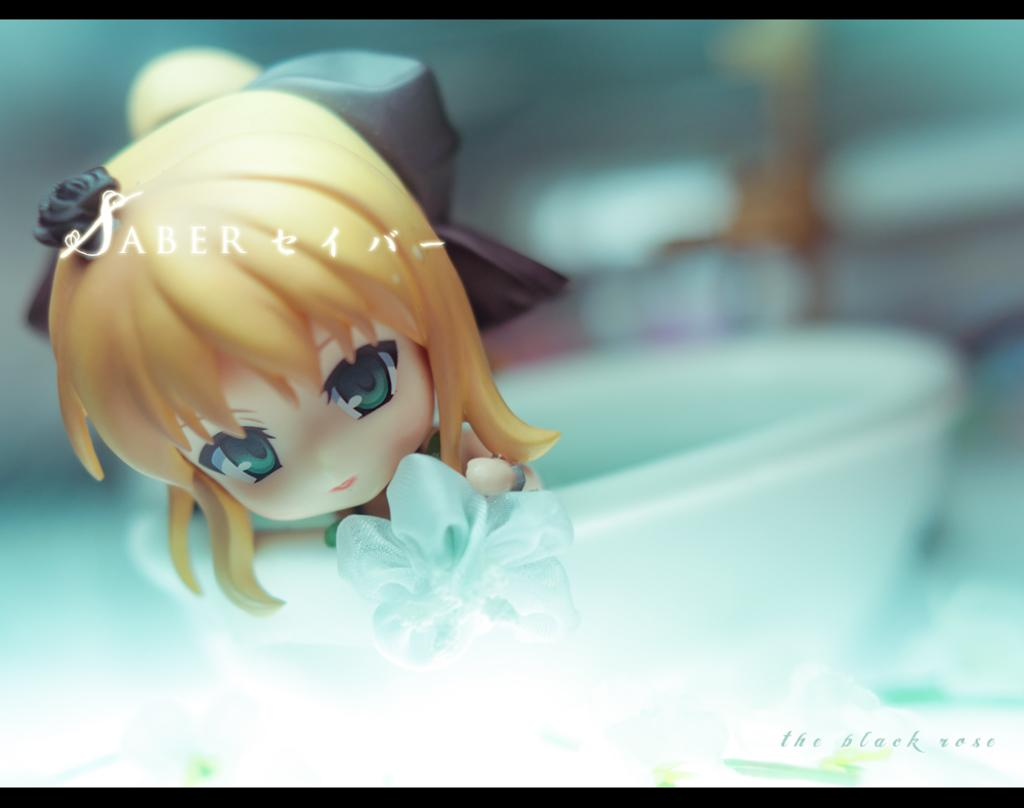What type of image is being described? The image is animated. What can be found in the image? There is a bowl in the image. What is inside the bowl? There is a toy in the bowl. Are there any words or letters in the image? Yes, there is text on the image. Can you see a donkey's leg in the image? There is no donkey or leg present in the image. What type of airport can be seen in the image? There is no airport present in the image. 